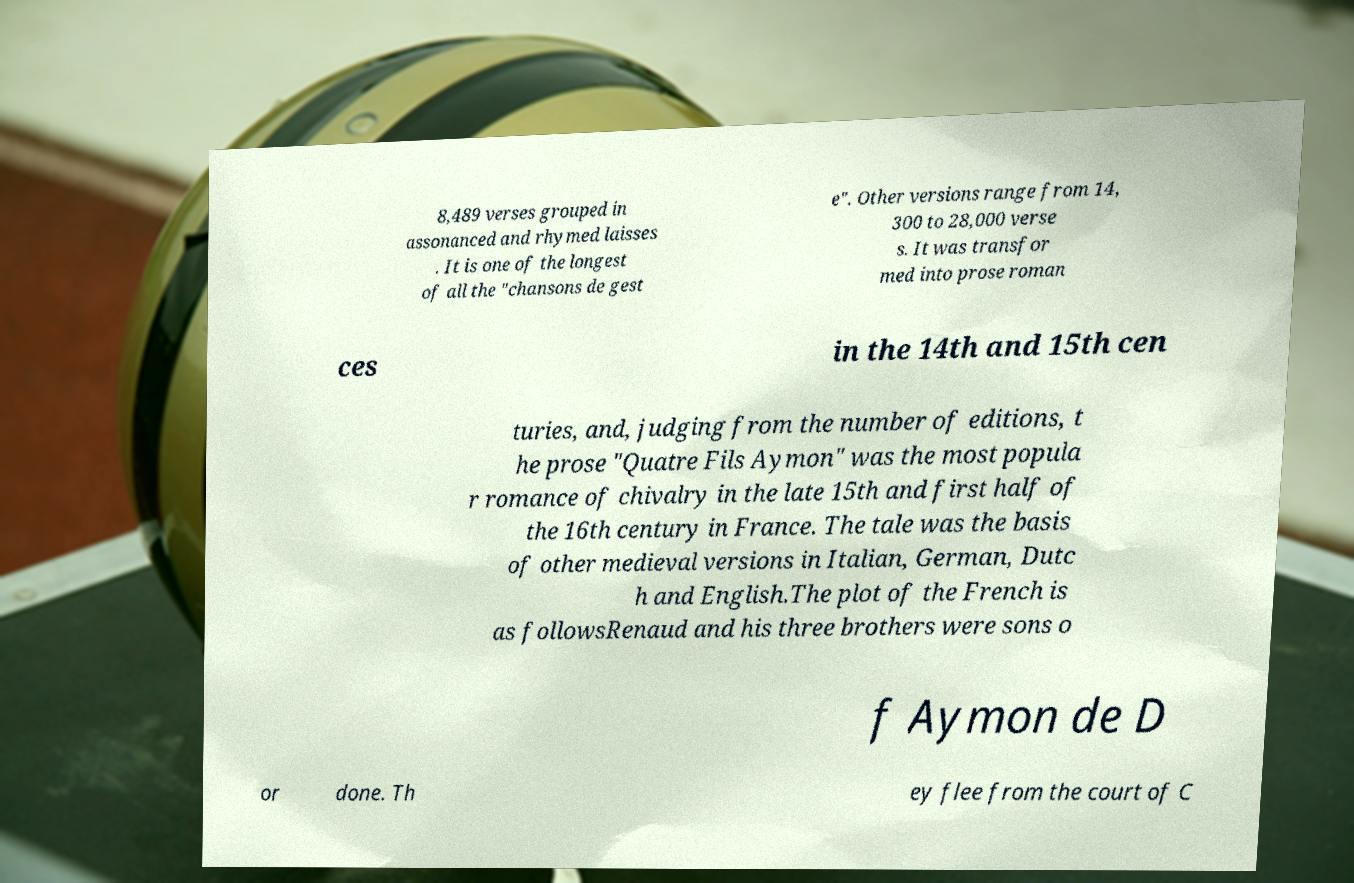For documentation purposes, I need the text within this image transcribed. Could you provide that? 8,489 verses grouped in assonanced and rhymed laisses . It is one of the longest of all the "chansons de gest e". Other versions range from 14, 300 to 28,000 verse s. It was transfor med into prose roman ces in the 14th and 15th cen turies, and, judging from the number of editions, t he prose "Quatre Fils Aymon" was the most popula r romance of chivalry in the late 15th and first half of the 16th century in France. The tale was the basis of other medieval versions in Italian, German, Dutc h and English.The plot of the French is as followsRenaud and his three brothers were sons o f Aymon de D or done. Th ey flee from the court of C 